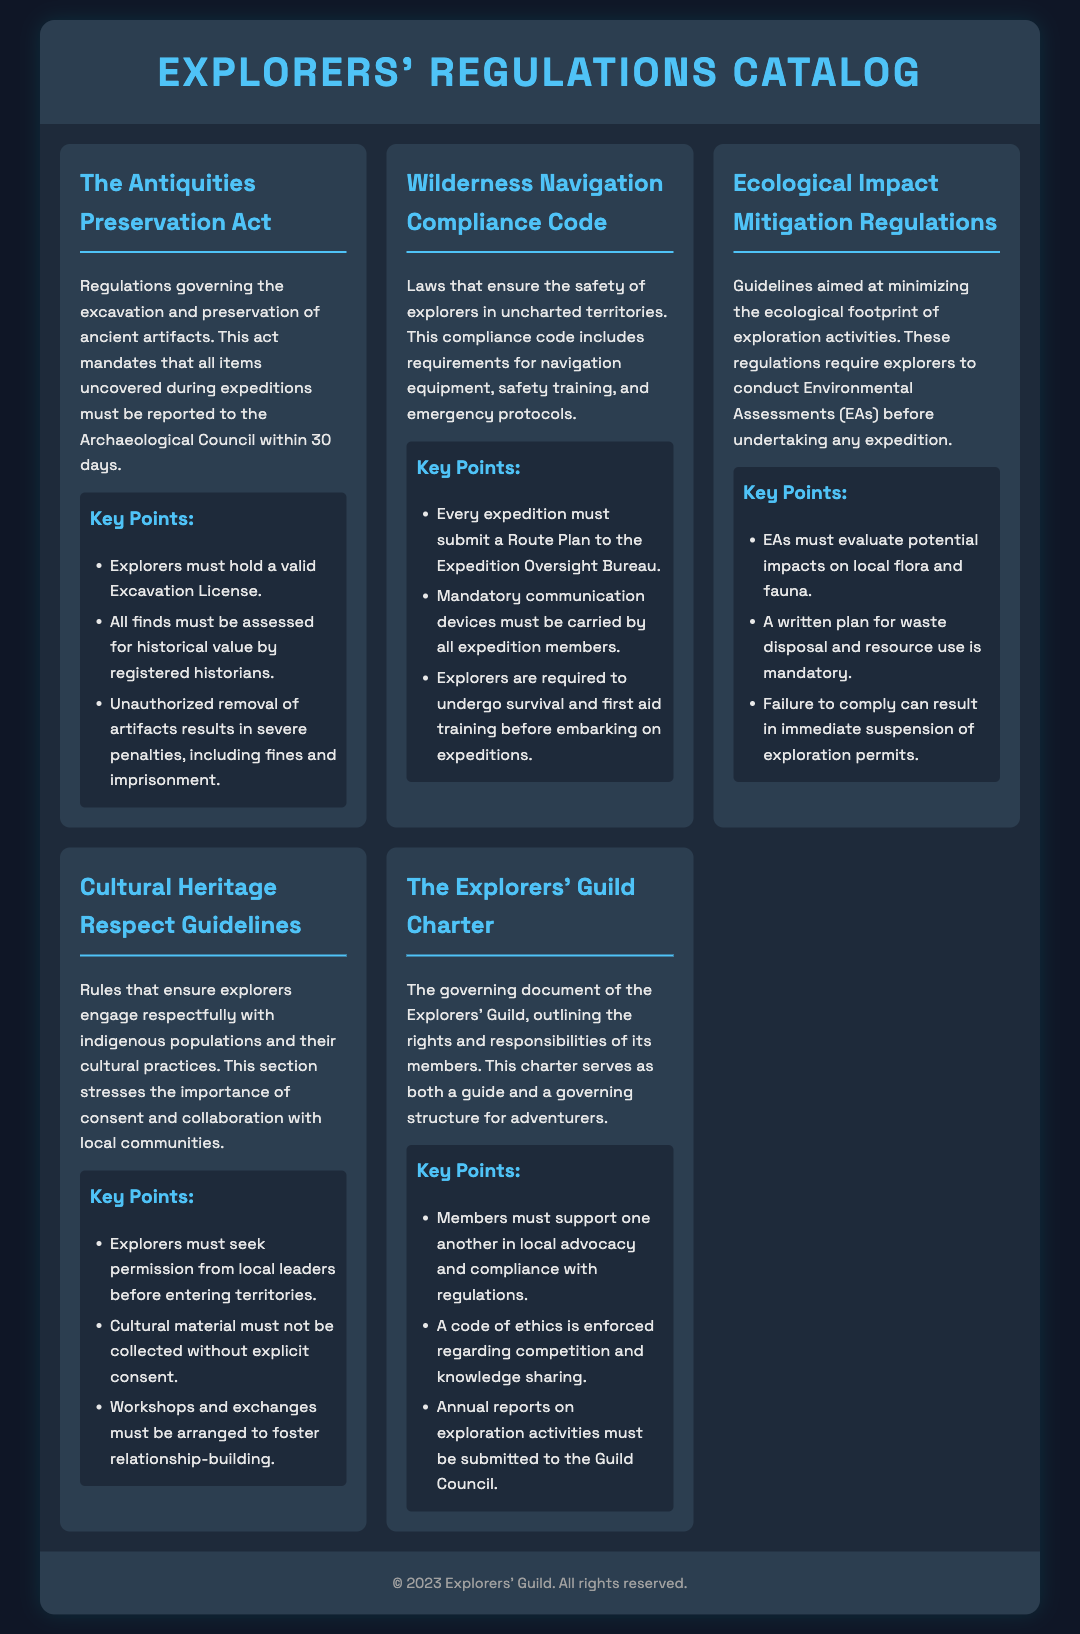What is the title of the first regulation? The first regulation is titled "The Antiquities Preservation Act."
Answer: The Antiquities Preservation Act How many key points are listed under the Wilderness Navigation Compliance Code? The Wilderness Navigation Compliance Code has three key points listed.
Answer: 3 What authority must be notified of archaeological findings within 30 days? According to the Antiquities Preservation Act, the Archaeological Council must be notified.
Answer: Archaeological Council What is required before any expedition according to the Ecological Impact Mitigation Regulations? Environmental Assessments (EAs) must be conducted before any expedition.
Answer: Environmental Assessments Which document outlines the rights and responsibilities of the Explorers' Guild members? The document that outlines this is called "The Explorers' Guild Charter."
Answer: The Explorers' Guild Charter What is the penalty for unauthorized removal of artifacts? The penalty includes severe penalties, including fines and imprisonment.
Answer: Severe penalties What does the Cultural Heritage Respect Guidelines emphasize? These guidelines emphasize the importance of consent and collaboration with local communities.
Answer: Consent and collaboration How many regulations are included in the catalog? The catalog contains five regulations listed.
Answer: Five 